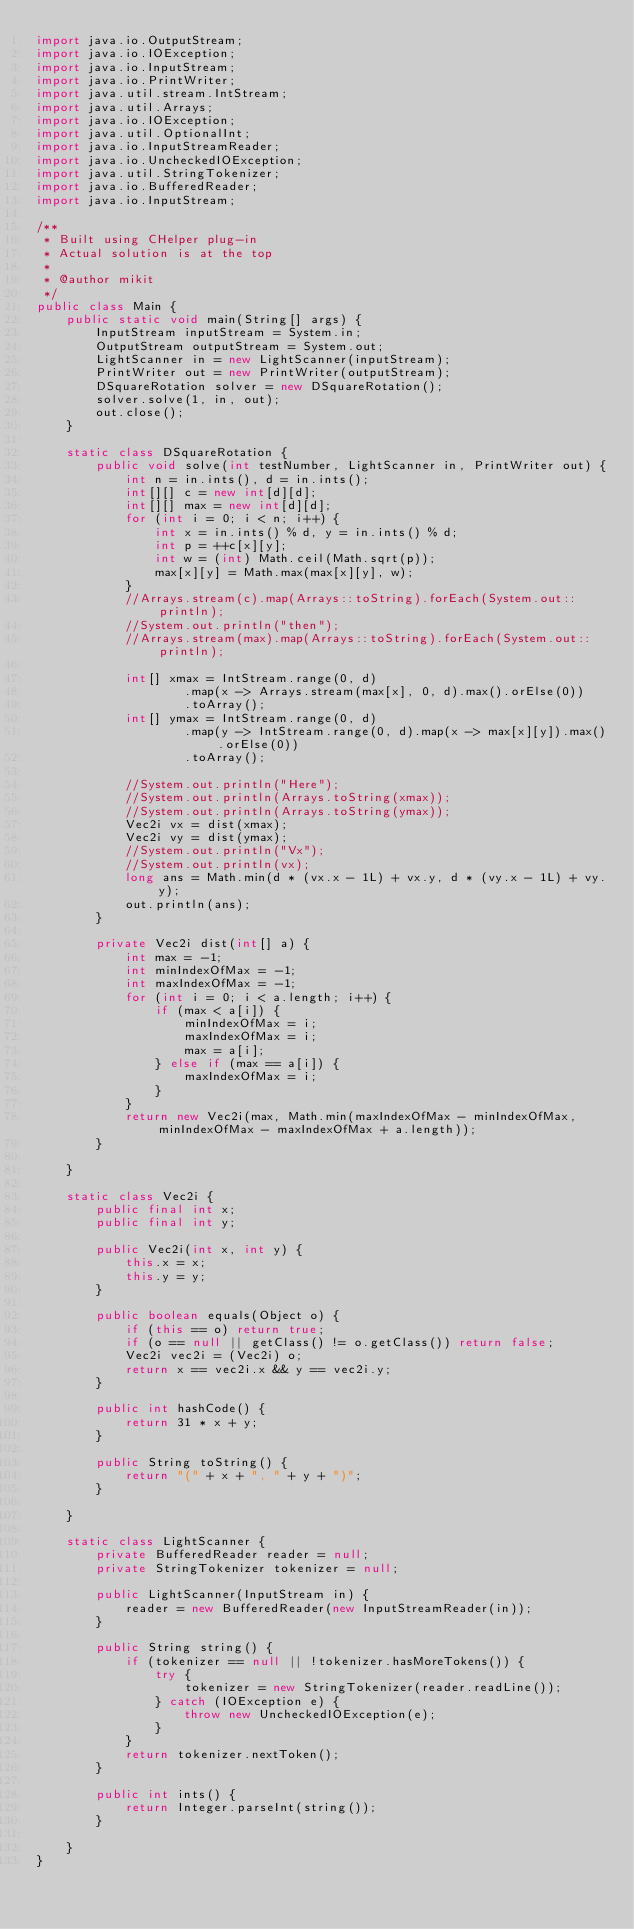<code> <loc_0><loc_0><loc_500><loc_500><_Java_>import java.io.OutputStream;
import java.io.IOException;
import java.io.InputStream;
import java.io.PrintWriter;
import java.util.stream.IntStream;
import java.util.Arrays;
import java.io.IOException;
import java.util.OptionalInt;
import java.io.InputStreamReader;
import java.io.UncheckedIOException;
import java.util.StringTokenizer;
import java.io.BufferedReader;
import java.io.InputStream;

/**
 * Built using CHelper plug-in
 * Actual solution is at the top
 *
 * @author mikit
 */
public class Main {
    public static void main(String[] args) {
        InputStream inputStream = System.in;
        OutputStream outputStream = System.out;
        LightScanner in = new LightScanner(inputStream);
        PrintWriter out = new PrintWriter(outputStream);
        DSquareRotation solver = new DSquareRotation();
        solver.solve(1, in, out);
        out.close();
    }

    static class DSquareRotation {
        public void solve(int testNumber, LightScanner in, PrintWriter out) {
            int n = in.ints(), d = in.ints();
            int[][] c = new int[d][d];
            int[][] max = new int[d][d];
            for (int i = 0; i < n; i++) {
                int x = in.ints() % d, y = in.ints() % d;
                int p = ++c[x][y];
                int w = (int) Math.ceil(Math.sqrt(p));
                max[x][y] = Math.max(max[x][y], w);
            }
            //Arrays.stream(c).map(Arrays::toString).forEach(System.out::println);
            //System.out.println("then");
            //Arrays.stream(max).map(Arrays::toString).forEach(System.out::println);

            int[] xmax = IntStream.range(0, d)
                    .map(x -> Arrays.stream(max[x], 0, d).max().orElse(0))
                    .toArray();
            int[] ymax = IntStream.range(0, d)
                    .map(y -> IntStream.range(0, d).map(x -> max[x][y]).max().orElse(0))
                    .toArray();

            //System.out.println("Here");
            //System.out.println(Arrays.toString(xmax));
            //System.out.println(Arrays.toString(ymax));
            Vec2i vx = dist(xmax);
            Vec2i vy = dist(ymax);
            //System.out.println("Vx");
            //System.out.println(vx);
            long ans = Math.min(d * (vx.x - 1L) + vx.y, d * (vy.x - 1L) + vy.y);
            out.println(ans);
        }

        private Vec2i dist(int[] a) {
            int max = -1;
            int minIndexOfMax = -1;
            int maxIndexOfMax = -1;
            for (int i = 0; i < a.length; i++) {
                if (max < a[i]) {
                    minIndexOfMax = i;
                    maxIndexOfMax = i;
                    max = a[i];
                } else if (max == a[i]) {
                    maxIndexOfMax = i;
                }
            }
            return new Vec2i(max, Math.min(maxIndexOfMax - minIndexOfMax, minIndexOfMax - maxIndexOfMax + a.length));
        }

    }

    static class Vec2i {
        public final int x;
        public final int y;

        public Vec2i(int x, int y) {
            this.x = x;
            this.y = y;
        }

        public boolean equals(Object o) {
            if (this == o) return true;
            if (o == null || getClass() != o.getClass()) return false;
            Vec2i vec2i = (Vec2i) o;
            return x == vec2i.x && y == vec2i.y;
        }

        public int hashCode() {
            return 31 * x + y;
        }

        public String toString() {
            return "(" + x + ", " + y + ")";
        }

    }

    static class LightScanner {
        private BufferedReader reader = null;
        private StringTokenizer tokenizer = null;

        public LightScanner(InputStream in) {
            reader = new BufferedReader(new InputStreamReader(in));
        }

        public String string() {
            if (tokenizer == null || !tokenizer.hasMoreTokens()) {
                try {
                    tokenizer = new StringTokenizer(reader.readLine());
                } catch (IOException e) {
                    throw new UncheckedIOException(e);
                }
            }
            return tokenizer.nextToken();
        }

        public int ints() {
            return Integer.parseInt(string());
        }

    }
}

</code> 